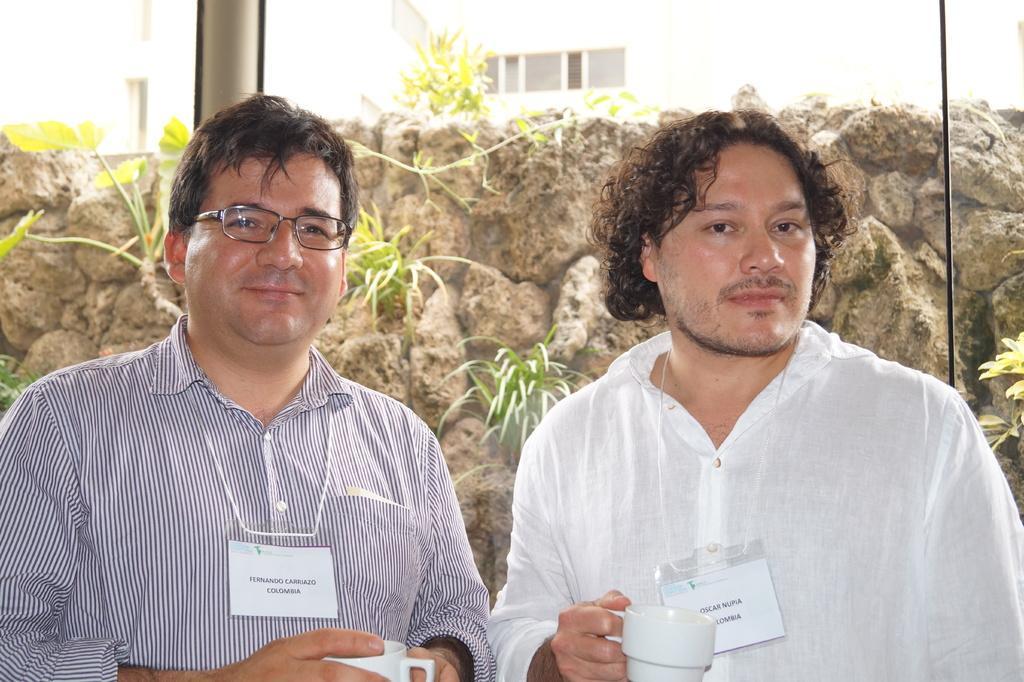In one or two sentences, can you explain what this image depicts? In this image in the foreground I can see two people and both are holding cups. At the back I can see a rod, plants, rocks. 